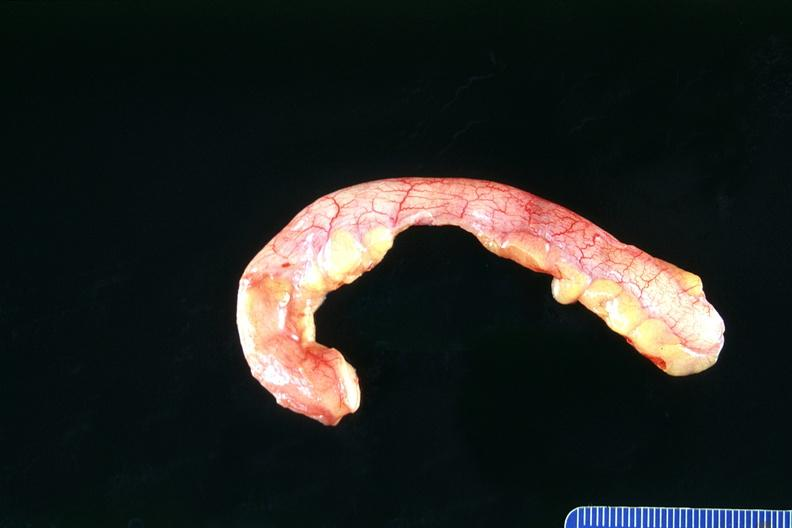where does this belong to?
Answer the question using a single word or phrase. Gastrointestinal system 